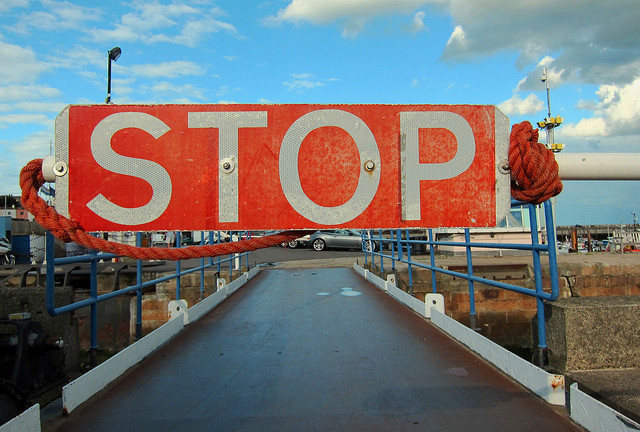Are there any vehicles in the image? Yes, there is a single car visible in the distance beyond the stop sign, parked at the edge of the area.  What might the weather conditions be like in the image? The weather conditions seem favorable with clear skies and ample sunlight, suggesting it is a fine day. 